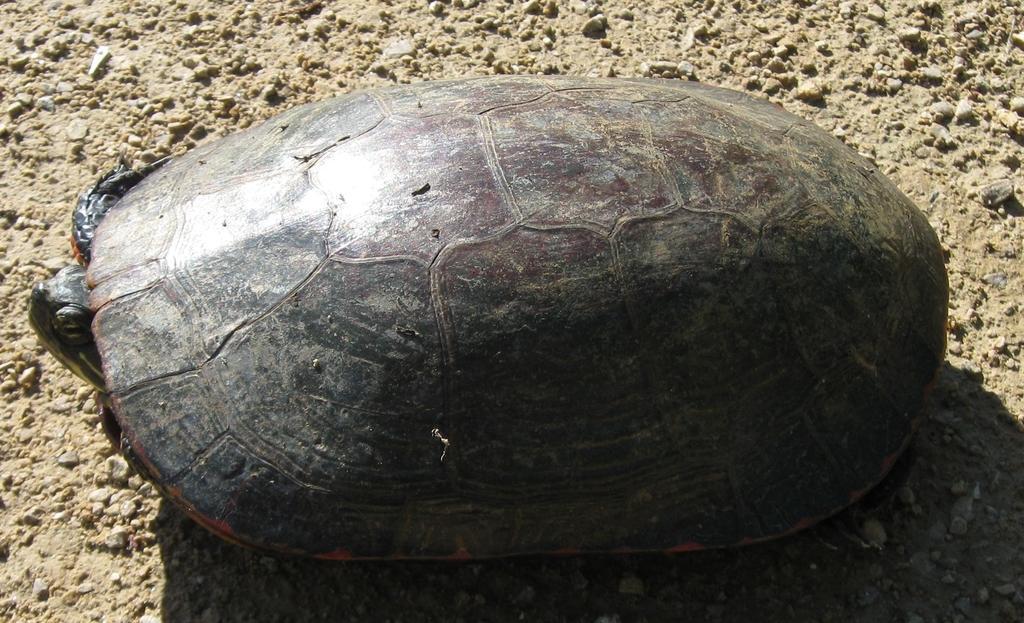Could you give a brief overview of what you see in this image? In this image we can see a tortoise on the sand. 